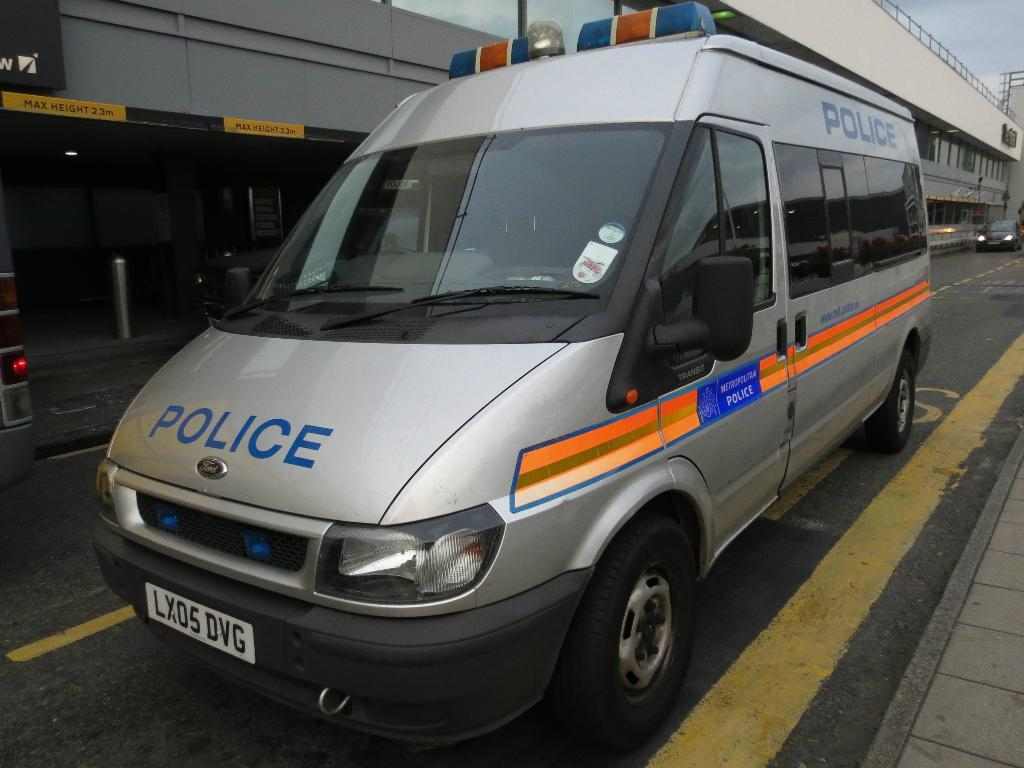Provide a one-sentence caption for the provided image. A grey Ford van that says Police on the front and the side. 